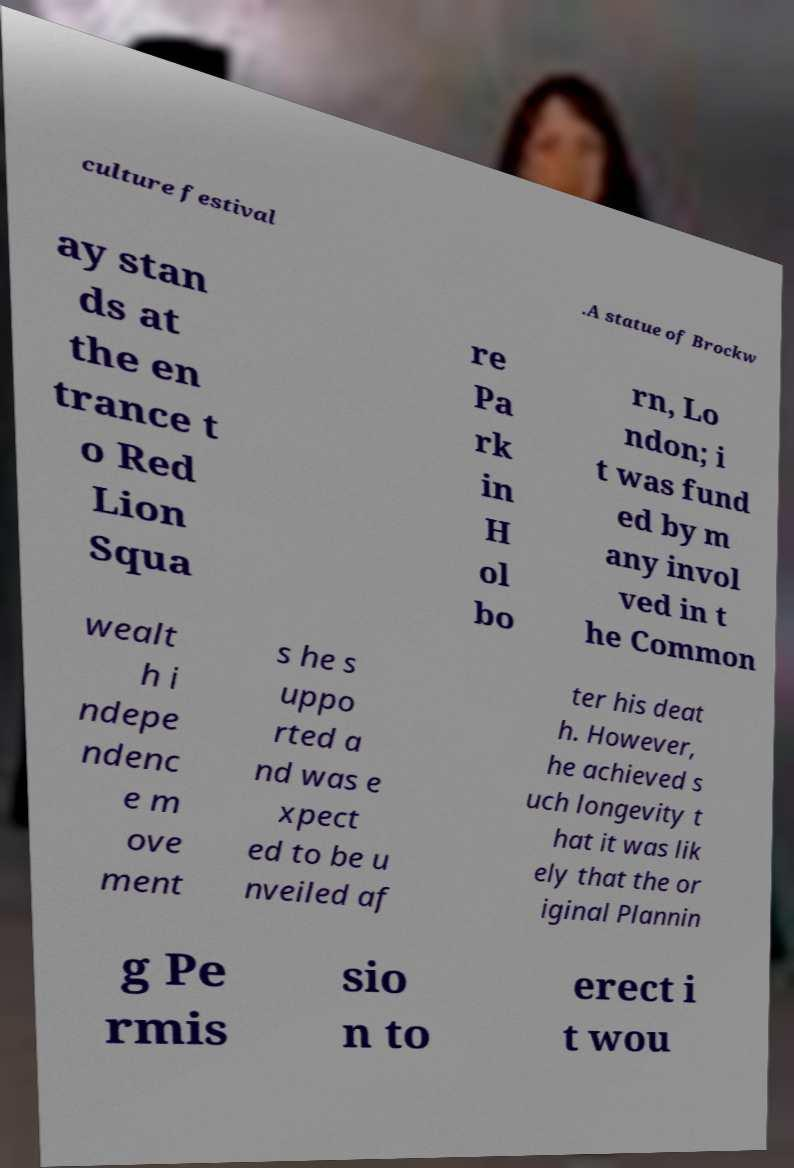Could you extract and type out the text from this image? culture festival .A statue of Brockw ay stan ds at the en trance t o Red Lion Squa re Pa rk in H ol bo rn, Lo ndon; i t was fund ed by m any invol ved in t he Common wealt h i ndepe ndenc e m ove ment s he s uppo rted a nd was e xpect ed to be u nveiled af ter his deat h. However, he achieved s uch longevity t hat it was lik ely that the or iginal Plannin g Pe rmis sio n to erect i t wou 